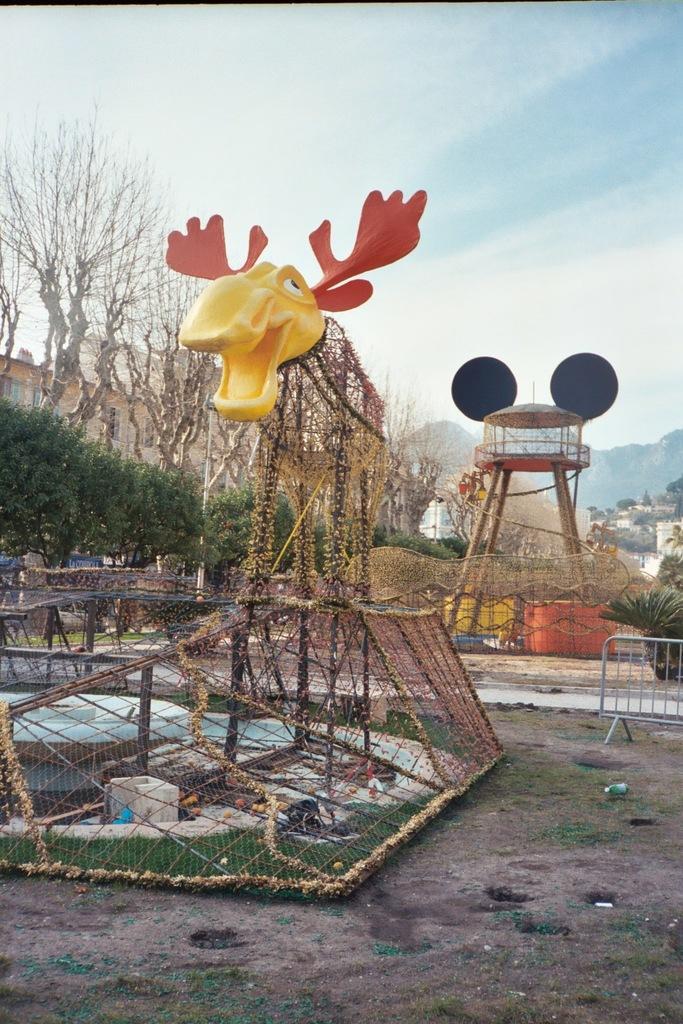Please provide a concise description of this image. In this image I can see in the middle there is the structure in the shape of an animal. On the left side there are trees, at the top it is the sky. 